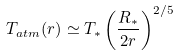Convert formula to latex. <formula><loc_0><loc_0><loc_500><loc_500>T _ { a t m } ( r ) \simeq T _ { \ast } \left ( \frac { R _ { \ast } } { 2 r } \right ) ^ { 2 / 5 }</formula> 